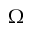Convert formula to latex. <formula><loc_0><loc_0><loc_500><loc_500>\Omega</formula> 